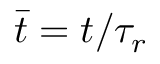<formula> <loc_0><loc_0><loc_500><loc_500>\bar { t } = t / \tau _ { r }</formula> 